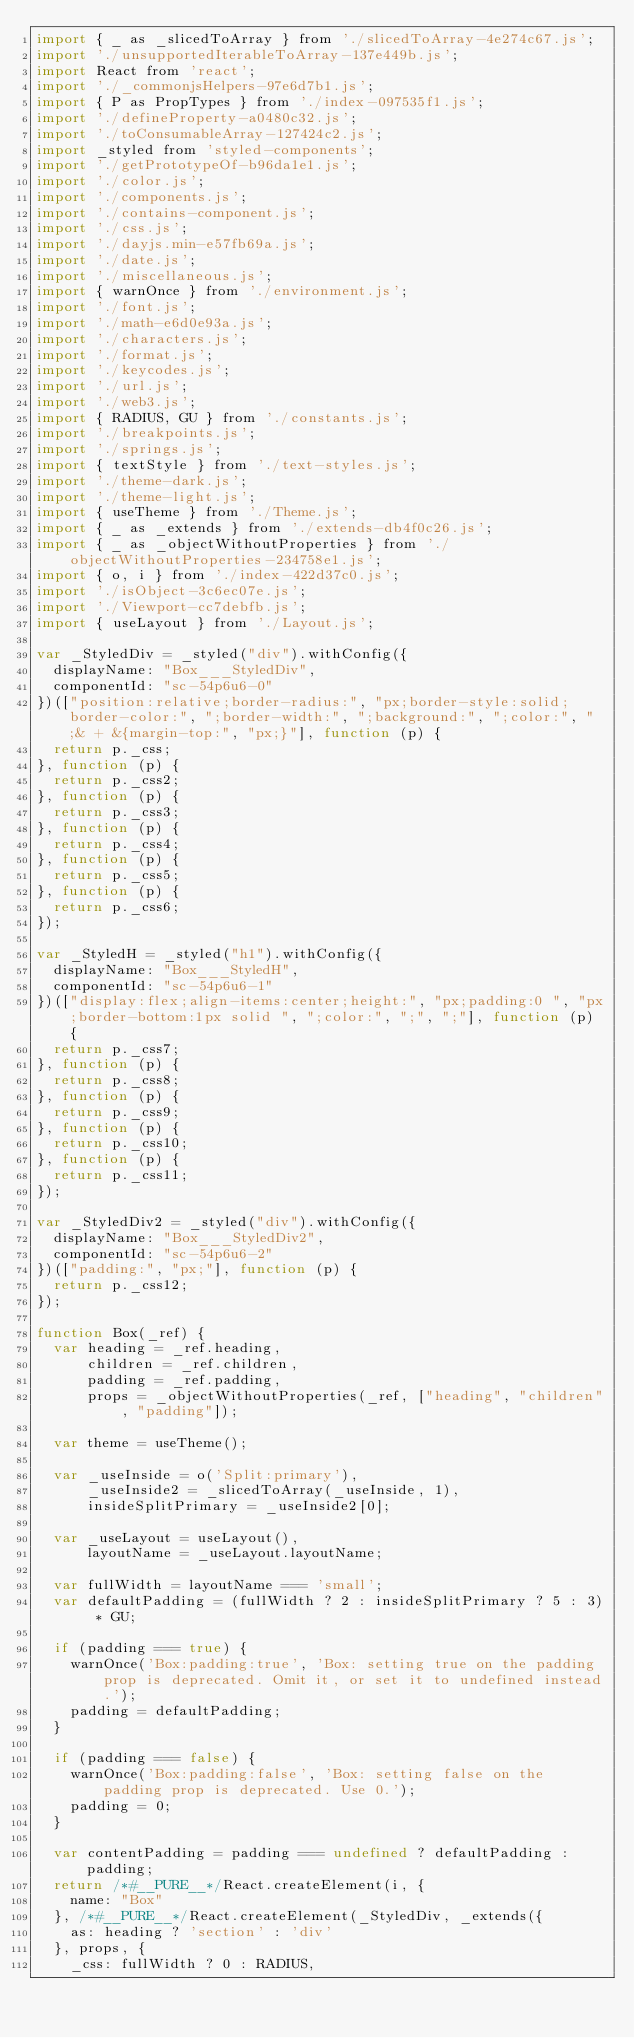Convert code to text. <code><loc_0><loc_0><loc_500><loc_500><_JavaScript_>import { _ as _slicedToArray } from './slicedToArray-4e274c67.js';
import './unsupportedIterableToArray-137e449b.js';
import React from 'react';
import './_commonjsHelpers-97e6d7b1.js';
import { P as PropTypes } from './index-097535f1.js';
import './defineProperty-a0480c32.js';
import './toConsumableArray-127424c2.js';
import _styled from 'styled-components';
import './getPrototypeOf-b96da1e1.js';
import './color.js';
import './components.js';
import './contains-component.js';
import './css.js';
import './dayjs.min-e57fb69a.js';
import './date.js';
import './miscellaneous.js';
import { warnOnce } from './environment.js';
import './font.js';
import './math-e6d0e93a.js';
import './characters.js';
import './format.js';
import './keycodes.js';
import './url.js';
import './web3.js';
import { RADIUS, GU } from './constants.js';
import './breakpoints.js';
import './springs.js';
import { textStyle } from './text-styles.js';
import './theme-dark.js';
import './theme-light.js';
import { useTheme } from './Theme.js';
import { _ as _extends } from './extends-db4f0c26.js';
import { _ as _objectWithoutProperties } from './objectWithoutProperties-234758e1.js';
import { o, i } from './index-422d37c0.js';
import './isObject-3c6ec07e.js';
import './Viewport-cc7debfb.js';
import { useLayout } from './Layout.js';

var _StyledDiv = _styled("div").withConfig({
  displayName: "Box___StyledDiv",
  componentId: "sc-54p6u6-0"
})(["position:relative;border-radius:", "px;border-style:solid;border-color:", ";border-width:", ";background:", ";color:", ";& + &{margin-top:", "px;}"], function (p) {
  return p._css;
}, function (p) {
  return p._css2;
}, function (p) {
  return p._css3;
}, function (p) {
  return p._css4;
}, function (p) {
  return p._css5;
}, function (p) {
  return p._css6;
});

var _StyledH = _styled("h1").withConfig({
  displayName: "Box___StyledH",
  componentId: "sc-54p6u6-1"
})(["display:flex;align-items:center;height:", "px;padding:0 ", "px;border-bottom:1px solid ", ";color:", ";", ";"], function (p) {
  return p._css7;
}, function (p) {
  return p._css8;
}, function (p) {
  return p._css9;
}, function (p) {
  return p._css10;
}, function (p) {
  return p._css11;
});

var _StyledDiv2 = _styled("div").withConfig({
  displayName: "Box___StyledDiv2",
  componentId: "sc-54p6u6-2"
})(["padding:", "px;"], function (p) {
  return p._css12;
});

function Box(_ref) {
  var heading = _ref.heading,
      children = _ref.children,
      padding = _ref.padding,
      props = _objectWithoutProperties(_ref, ["heading", "children", "padding"]);

  var theme = useTheme();

  var _useInside = o('Split:primary'),
      _useInside2 = _slicedToArray(_useInside, 1),
      insideSplitPrimary = _useInside2[0];

  var _useLayout = useLayout(),
      layoutName = _useLayout.layoutName;

  var fullWidth = layoutName === 'small';
  var defaultPadding = (fullWidth ? 2 : insideSplitPrimary ? 5 : 3) * GU;

  if (padding === true) {
    warnOnce('Box:padding:true', 'Box: setting true on the padding prop is deprecated. Omit it, or set it to undefined instead.');
    padding = defaultPadding;
  }

  if (padding === false) {
    warnOnce('Box:padding:false', 'Box: setting false on the padding prop is deprecated. Use 0.');
    padding = 0;
  }

  var contentPadding = padding === undefined ? defaultPadding : padding;
  return /*#__PURE__*/React.createElement(i, {
    name: "Box"
  }, /*#__PURE__*/React.createElement(_StyledDiv, _extends({
    as: heading ? 'section' : 'div'
  }, props, {
    _css: fullWidth ? 0 : RADIUS,</code> 